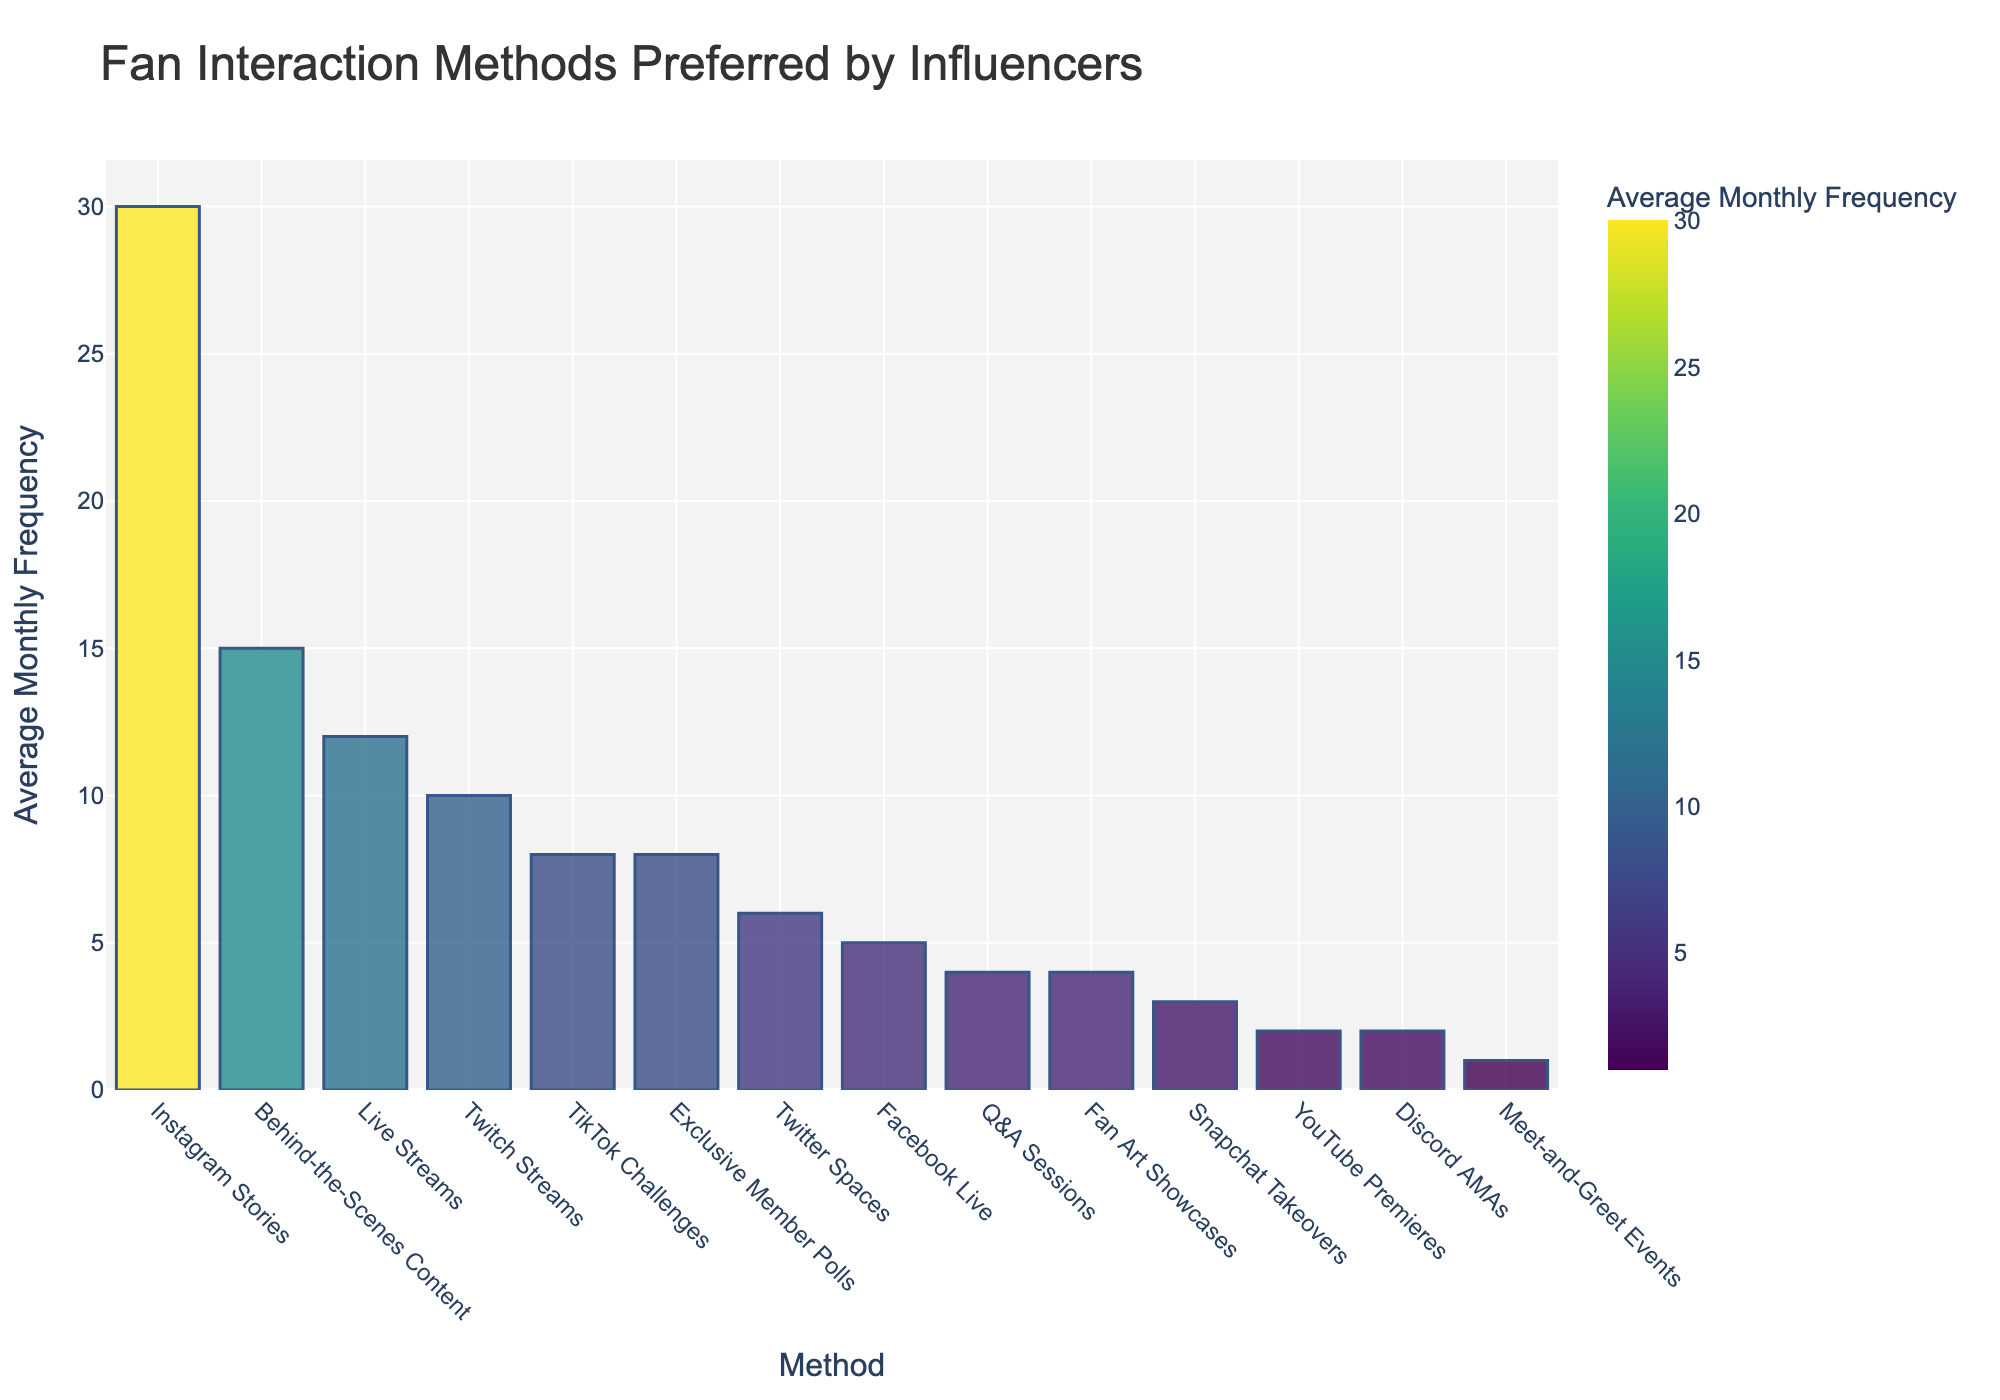Which interaction method is utilized most frequently by influencers? The highest bar in the chart represents the most frequently used interaction method. The bar for "Instagram Stories" is the tallest, indicating it is the most frequent.
Answer: Instagram Stories What is the total average monthly frequency for Live Streams and Q&A Sessions? Sum the average monthly frequencies of Live Streams (12) and Q&A Sessions (4): 12 + 4 = 16.
Answer: 16 Which interaction methods have an average monthly frequency greater than 10? Identify all the bars with a height representing a frequency greater than 10. These bars are "Instagram Stories" (30), "Behind-the-Scenes Content" (15), and "Live Streams" (12).
Answer: Instagram Stories, Behind-the-Scenes Content, Live Streams Compare the frequencies of YouTube Premieres and Behind-the-Scenes Content. Which one is utilized more frequently? Compare the heights of the bars for YouTube Premieres and Behind-the-Scenes Content. The bar for Behind-the-Scenes Content (15) is taller than that for YouTube Premieres (2).
Answer: Behind-the-Scenes Content How much more frequently are TikTok Challenges conducted compared to Snapchat Takeovers? Subtract the average monthly frequency of Snapchat Takeovers (3) from that of TikTok Challenges (8): 8 - 3 = 5.
Answer: 5 What is the average frequency of Q&A Sessions, Meet-and-Greet Events, and Discord AMAs? Calculate the arithmetic mean of the frequencies for Q&A Sessions (4), Meet-and-Greet Events (1), and Discord AMAs (2): (4 + 1 + 2) / 3 = 2.33.
Answer: 2.33 Is the average monthly frequency of Facebook Live higher than that of Twitter Spaces? Compare the heights of the bars for Facebook Live (5) and Twitter Spaces (6). The bar for Twitter Spaces is taller, indicating it has a higher frequency.
Answer: No What are the interaction methods with an average monthly frequency of 2? Identify the bars with a height representing a frequency of 2. These bars correspond to "YouTube Premieres" and "Discord AMAs."
Answer: YouTube Premieres, Discord AMAs Calculate the difference in average monthly frequency between the most and least frequently used interaction methods. The most frequent method is "Instagram Stories" (30) and the least is "Meet-and-Greet Events" (1). The difference is 30 - 1 = 29.
Answer: 29 